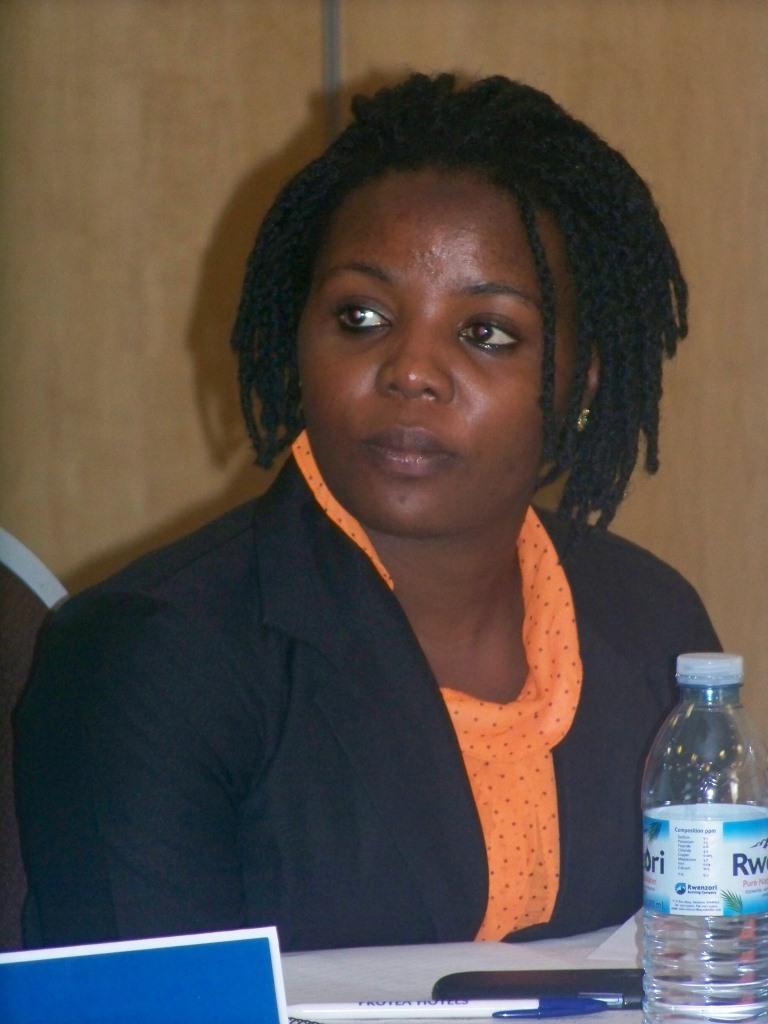Please provide a concise description of this image. A woman is located in the center of the image. She is black. She wore a blue suit with a orange scarf. There is table in front of her. There is a water bottle on it and few pens situated beside the bottle. 